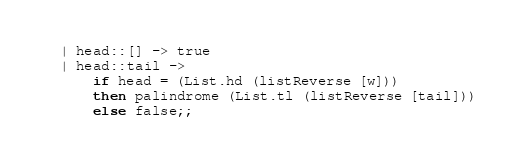<code> <loc_0><loc_0><loc_500><loc_500><_OCaml_>  | head::[] -> true
  | head::tail ->
      if head = (List.hd (listReverse [w]))
      then palindrome (List.tl (listReverse [tail]))
      else false;;
</code> 